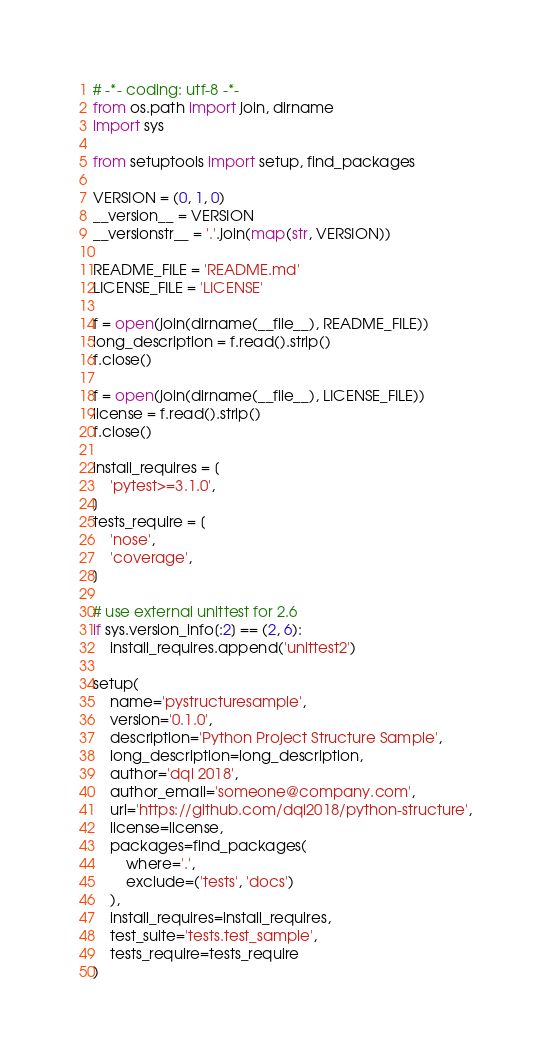Convert code to text. <code><loc_0><loc_0><loc_500><loc_500><_Python_># -*- coding: utf-8 -*-
from os.path import join, dirname
import sys

from setuptools import setup, find_packages

VERSION = (0, 1, 0)
__version__ = VERSION
__versionstr__ = '.'.join(map(str, VERSION))

README_FILE = 'README.md'
LICENSE_FILE = 'LICENSE'

f = open(join(dirname(__file__), README_FILE))
long_description = f.read().strip()
f.close()

f = open(join(dirname(__file__), LICENSE_FILE))
license = f.read().strip()
f.close()

install_requires = [
    'pytest>=3.1.0',
]
tests_require = [
    'nose',
    'coverage',
]

# use external unittest for 2.6
if sys.version_info[:2] == (2, 6):
    install_requires.append('unittest2')

setup(
    name='pystructuresample',
    version='0.1.0',
    description='Python Project Structure Sample',
    long_description=long_description,
    author='dqi 2018',
    author_email='someone@company.com',
    url='https://github.com/dqi2018/python-structure',
    license=license,
    packages=find_packages(
        where='.',
        exclude=('tests', 'docs')
    ),
    install_requires=install_requires,
    test_suite='tests.test_sample',
    tests_require=tests_require
)
</code> 